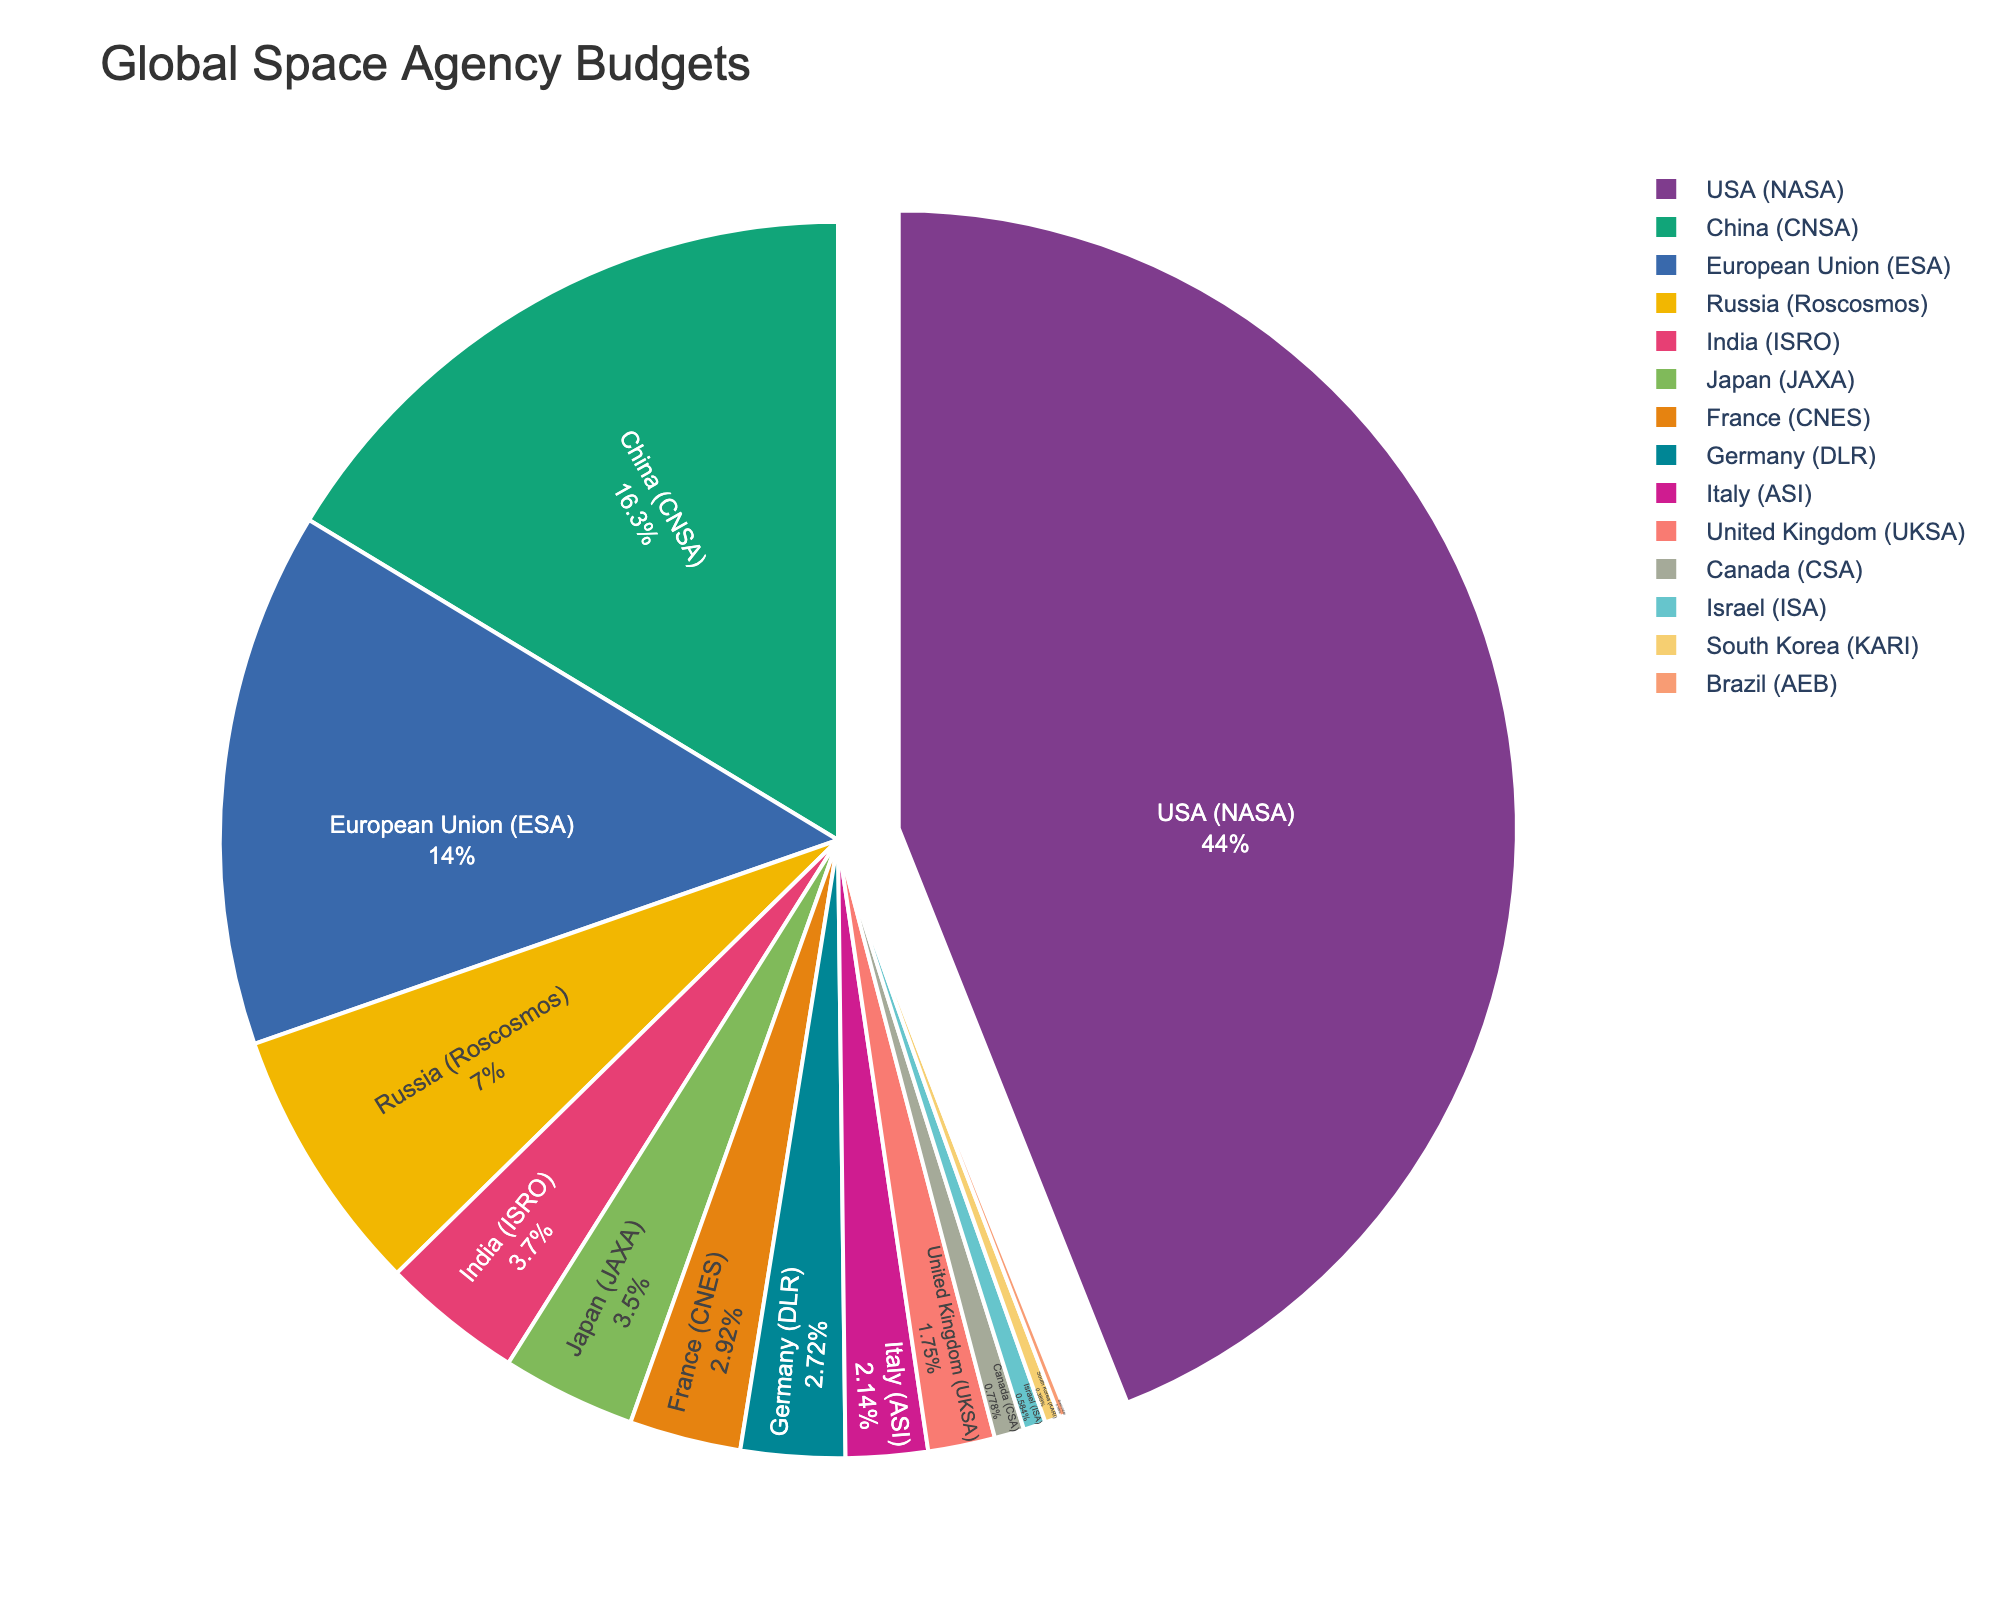Which country has the largest budget share? The largest slice of the pie chart is pulled out, indicating the country with the largest budget. In this case, the USA (NASA) has the largest share of the global space agency budgets.
Answer: USA (NASA) What is the combined budget of China (CNSA) and the European Union (ESA)? The budget for China (CNSA) is 8.4 billion USD and for the European Union (ESA) is 7.2 billion USD. Adding these two values gives 8.4 + 7.2.
Answer: 15.6 billion USD Which countries have a budget less than 1 billion USD? The countries with budget slices labeled as less than 1 billion USD in the pie chart are the United Kingdom (UKSA), Canada (CSA), Israel (ISA), South Korea (KARI), and Brazil (AEB).
Answer: United Kingdom (UKSA), Canada (CSA), Israel (ISA), South Korea (KARI), and Brazil (AEB) How does the budget of the Indian Space Research Organisation (ISRO) compare to that of the Japan Aerospace Exploration Agency (JAXA)? The pie chart shows that ISRO has a budget of 1.9 billion USD, while JAXA has a budget of 1.8 billion USD. 1.9 is slightly greater than 1.8.
Answer: ISRO has a slightly higher budget than JAXA What is the total budget for the top three space agencies? The top three space agencies by budget are USA (NASA) with 22.6 billion USD, China (CNSA) with 8.4 billion USD, and the European Union (ESA) with 7.2 billion USD. Adding these gives 22.6 + 8.4 + 7.2.
Answer: 38.2 billion USD What percentage of the total budget does Russia (Roscosmos) have? The total budget is the sum of all specified budgets, adding up to 51.9 billion USD. Roscosmos has a budget of 3.6 billion USD. The percentage is calculated as (3.6 / 51.9) * 100.
Answer: Approximately 6.93% Which countries have similar budget sizes within 0.1 billion USD differences? The pie chart indicates that Germany (DLR) has a budget of 1.4 billion USD and Italy (ASI) has a budget of 1.1 billion USD. The difference is 0.3 billion USD. No countries are depicted with a difference within 0.1 billion USD of each other. There are no countries meeting this criteria.
Answer: None 